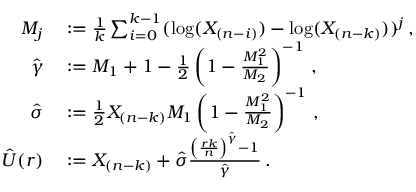Convert formula to latex. <formula><loc_0><loc_0><loc_500><loc_500>\begin{array} { r l } { M _ { j } } & \colon = \frac { 1 } { k } \sum _ { i = 0 } ^ { k - 1 } ( \log ( X _ { ( n - i ) } ) - \log ( X _ { ( n - k ) } ) ) ^ { j } \, , } \\ { \hat { \gamma } } & \colon = M _ { 1 } + 1 - \frac { 1 } { 2 } \left ( 1 - \frac { M _ { 1 } ^ { 2 } } { M _ { 2 } } \right ) ^ { - 1 } \, , } \\ { \hat { \sigma } } & \colon = \frac { 1 } { 2 } X _ { ( n - k ) } M _ { 1 } \left ( 1 - \frac { M _ { 1 } ^ { 2 } } { M _ { 2 } } \right ) ^ { - 1 } \, , } \\ { \hat { U } ( r ) } & \colon = X _ { ( n - k ) } + \hat { \sigma } \frac { \left ( \frac { r k } { n } \right ) ^ { \hat { \gamma } } - 1 } { \hat { \gamma } } \, . } \end{array}</formula> 